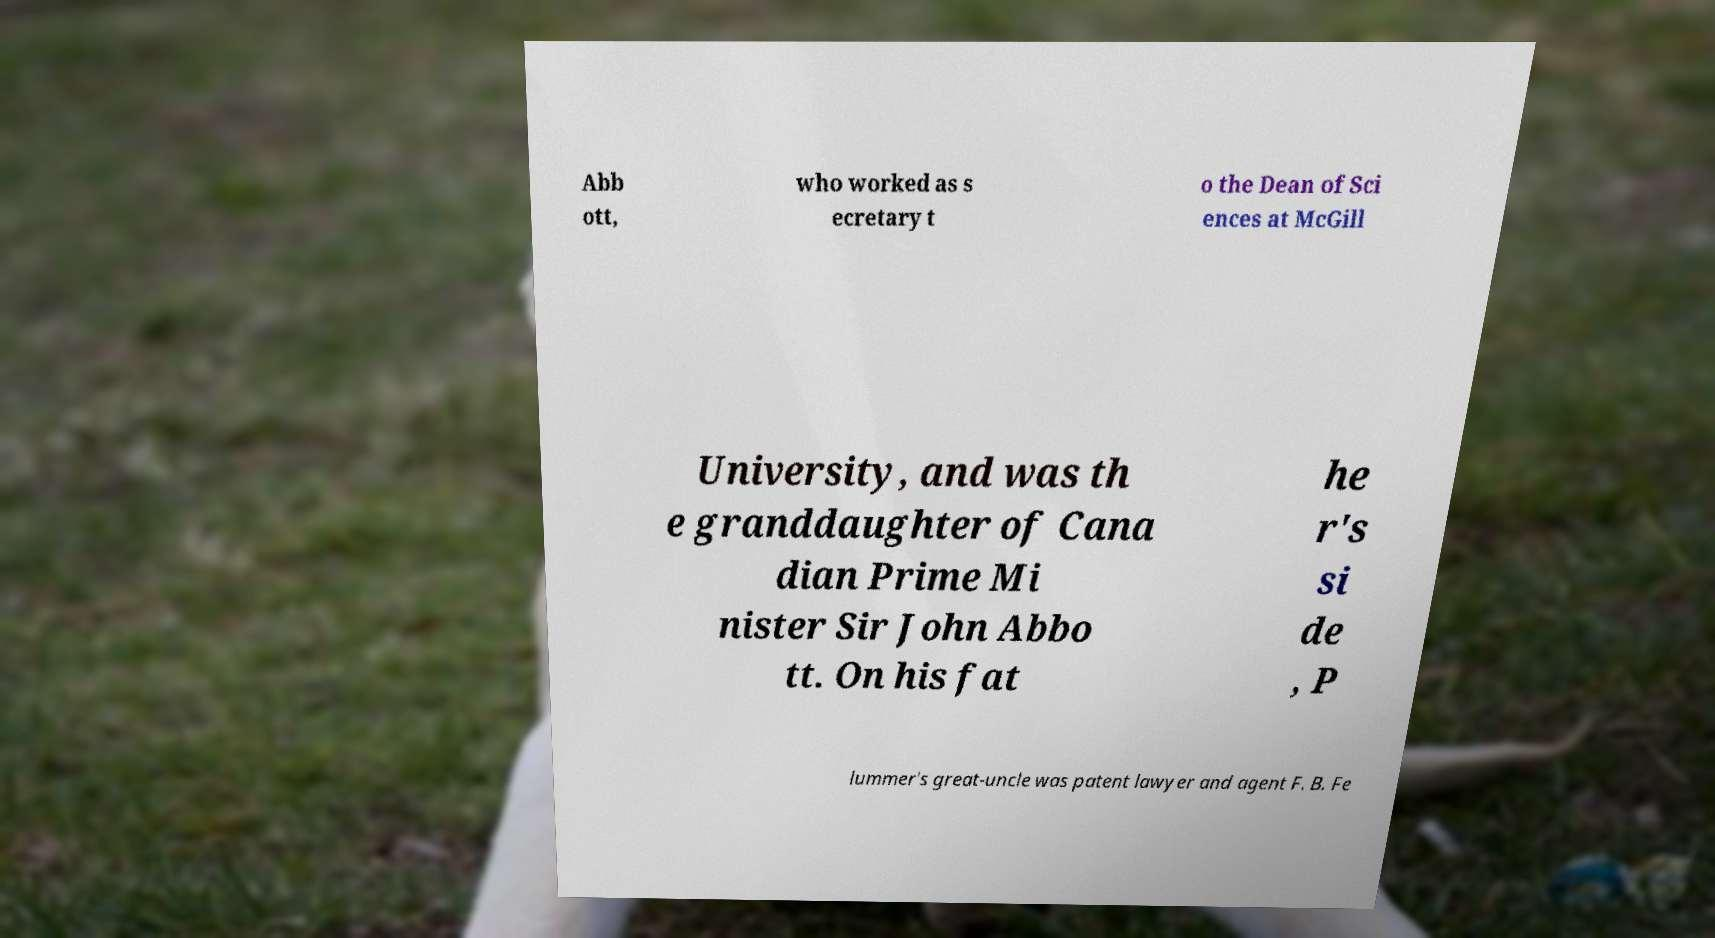Please identify and transcribe the text found in this image. Abb ott, who worked as s ecretary t o the Dean of Sci ences at McGill University, and was th e granddaughter of Cana dian Prime Mi nister Sir John Abbo tt. On his fat he r's si de , P lummer's great-uncle was patent lawyer and agent F. B. Fe 